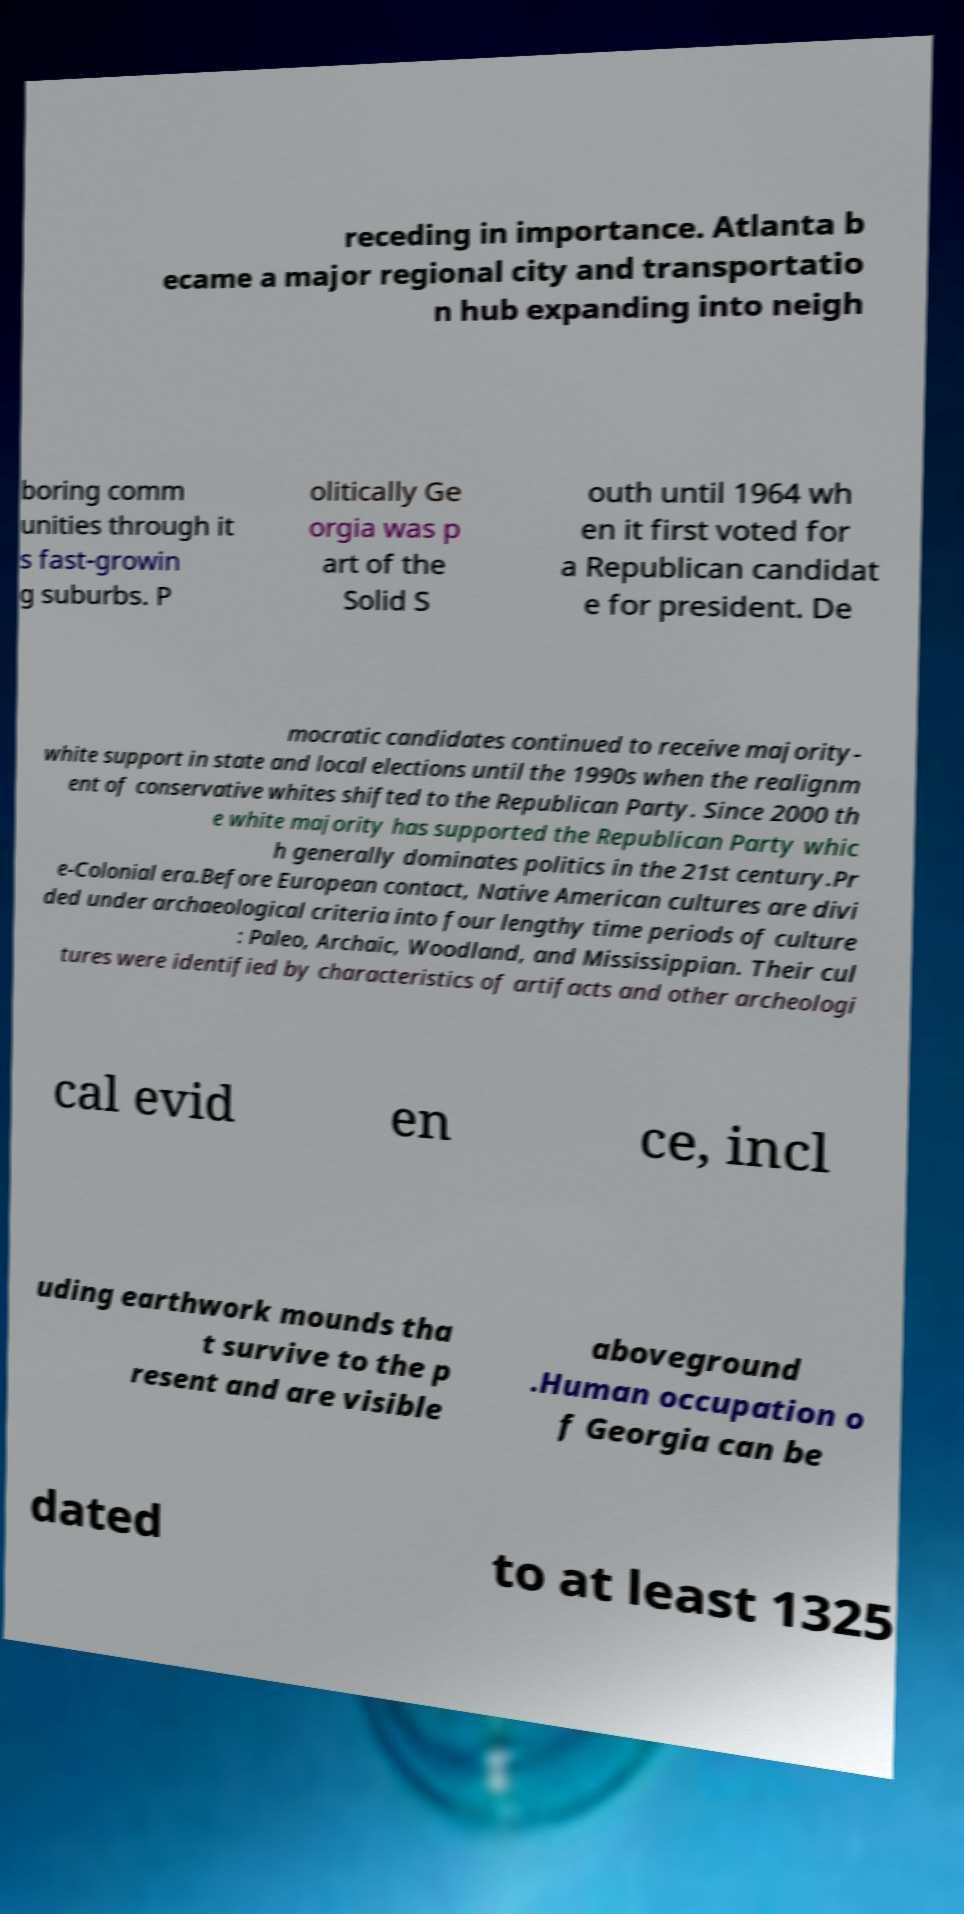Can you accurately transcribe the text from the provided image for me? receding in importance. Atlanta b ecame a major regional city and transportatio n hub expanding into neigh boring comm unities through it s fast-growin g suburbs. P olitically Ge orgia was p art of the Solid S outh until 1964 wh en it first voted for a Republican candidat e for president. De mocratic candidates continued to receive majority- white support in state and local elections until the 1990s when the realignm ent of conservative whites shifted to the Republican Party. Since 2000 th e white majority has supported the Republican Party whic h generally dominates politics in the 21st century.Pr e-Colonial era.Before European contact, Native American cultures are divi ded under archaeological criteria into four lengthy time periods of culture : Paleo, Archaic, Woodland, and Mississippian. Their cul tures were identified by characteristics of artifacts and other archeologi cal evid en ce, incl uding earthwork mounds tha t survive to the p resent and are visible aboveground .Human occupation o f Georgia can be dated to at least 1325 